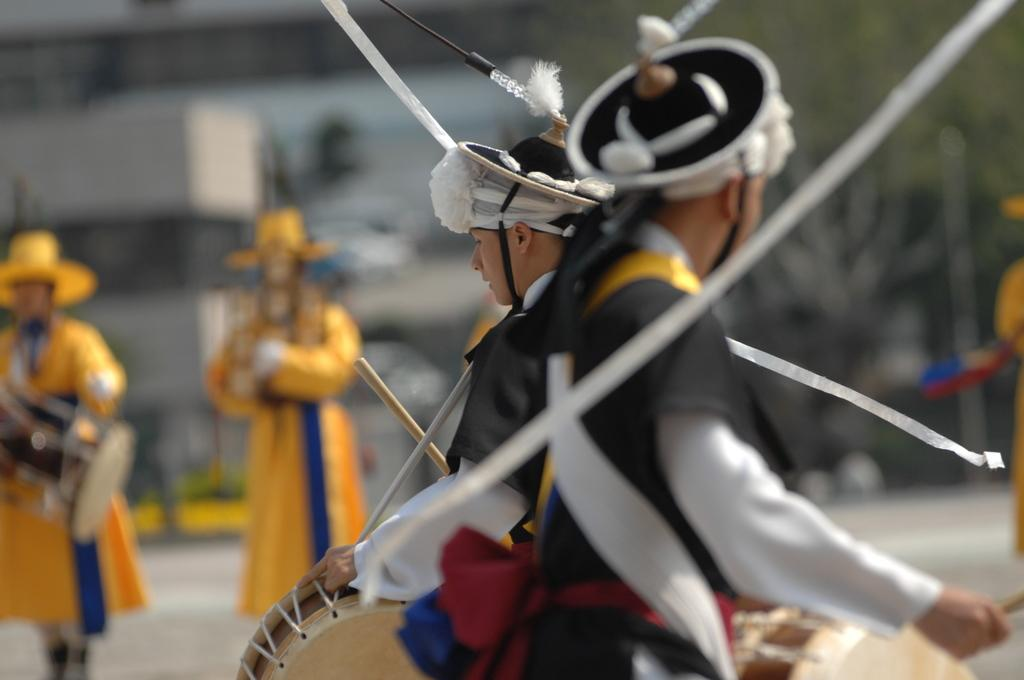How many people are present in the image? There are a few people in the image. What are some of the people doing in the image? Some people are holding objects in the image. Can you describe the background of the image? The background of the image is blurred. What type of vest can be seen on the person's knee in the image? There is no vest or person's knee visible in the image. 